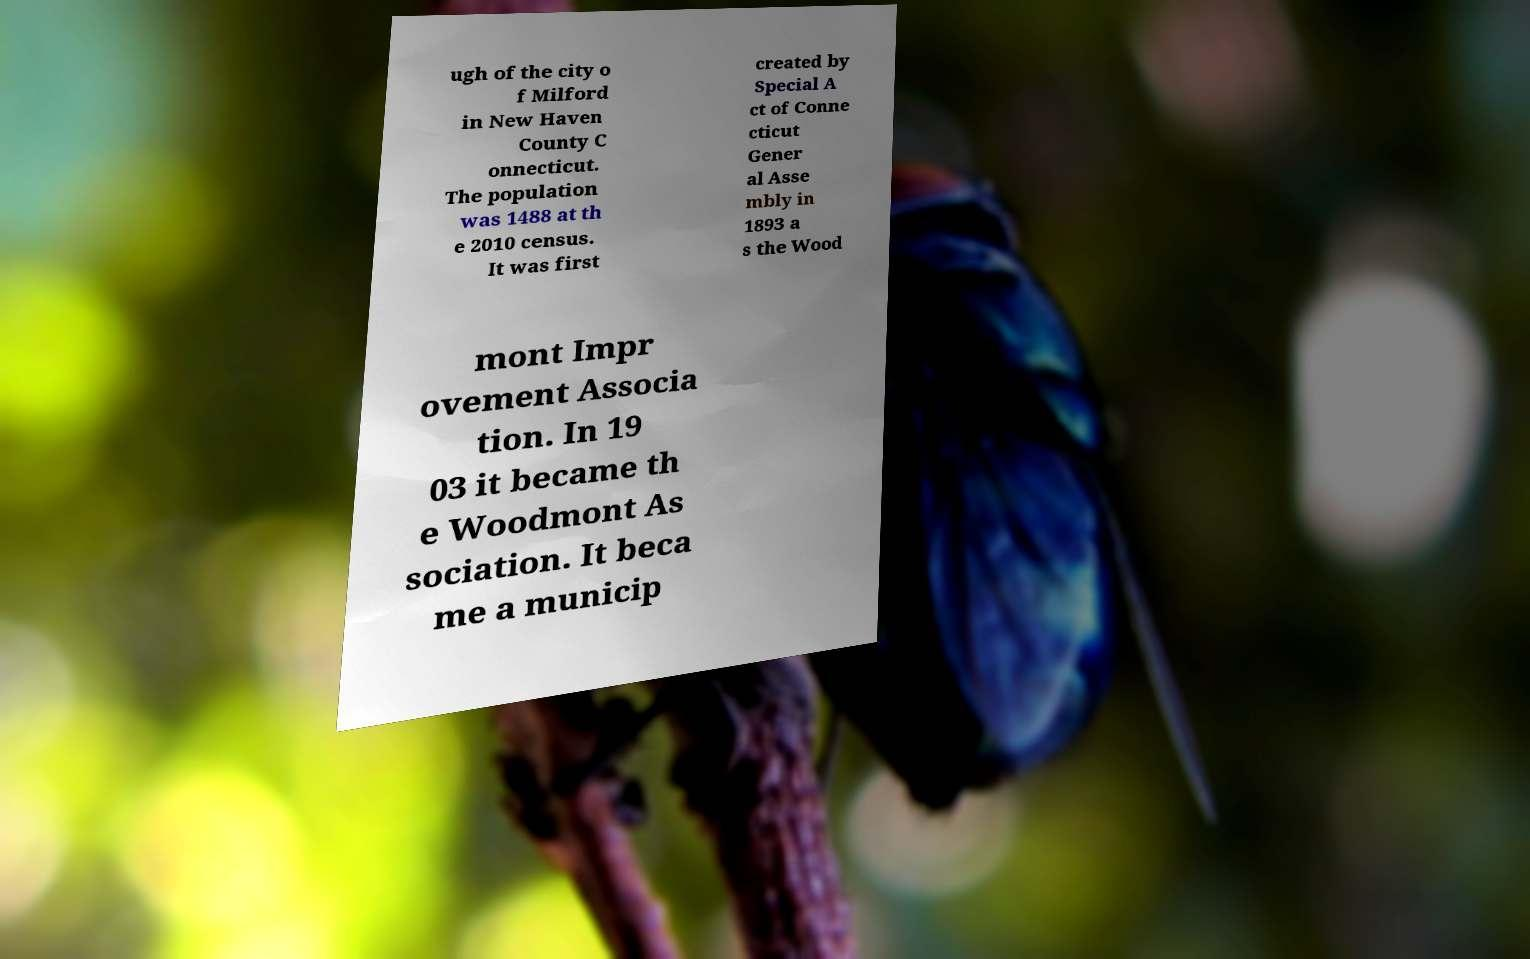What messages or text are displayed in this image? I need them in a readable, typed format. ugh of the city o f Milford in New Haven County C onnecticut. The population was 1488 at th e 2010 census. It was first created by Special A ct of Conne cticut Gener al Asse mbly in 1893 a s the Wood mont Impr ovement Associa tion. In 19 03 it became th e Woodmont As sociation. It beca me a municip 